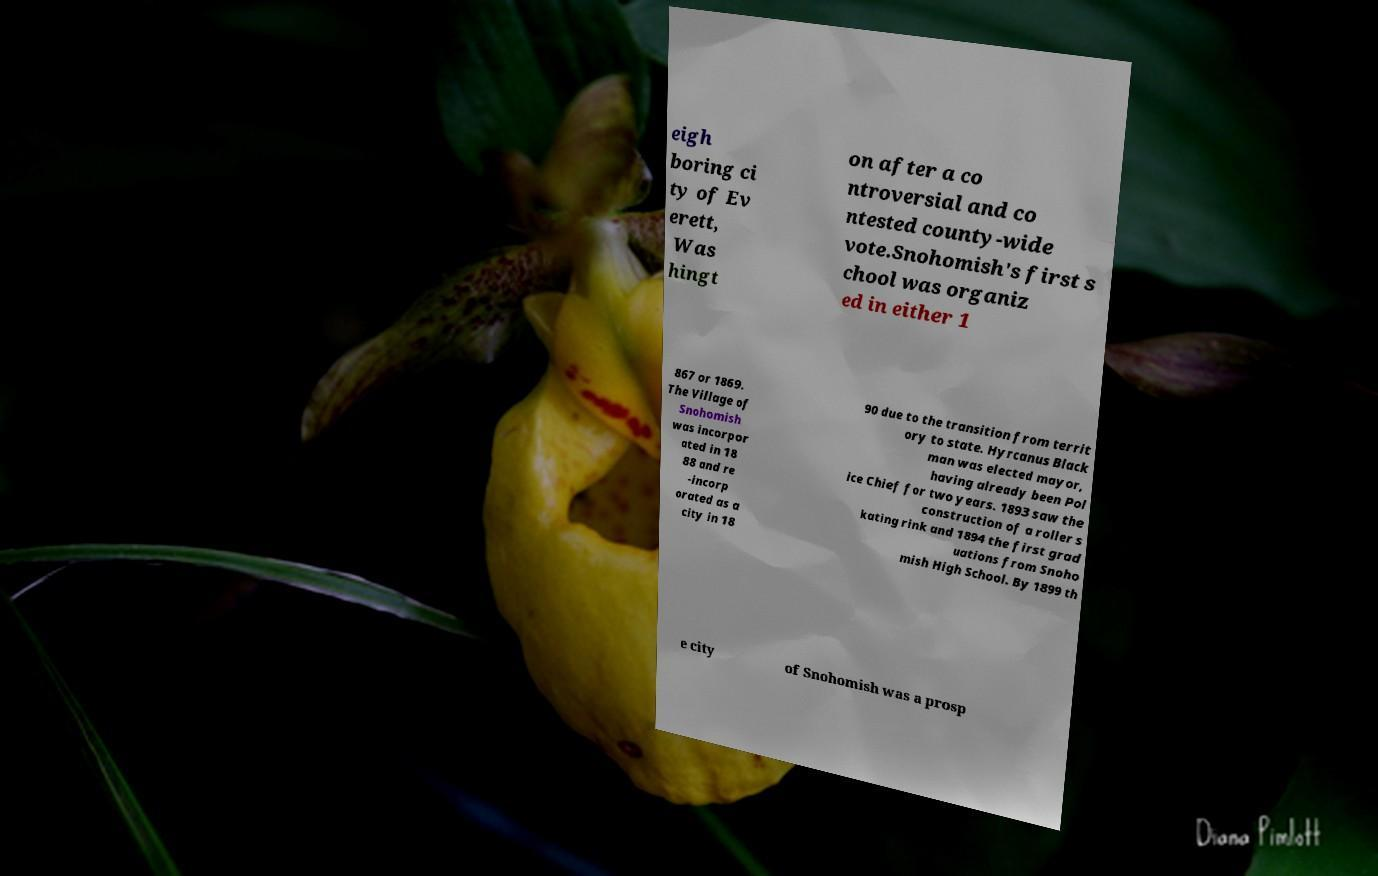Could you extract and type out the text from this image? eigh boring ci ty of Ev erett, Was hingt on after a co ntroversial and co ntested county-wide vote.Snohomish's first s chool was organiz ed in either 1 867 or 1869. The Village of Snohomish was incorpor ated in 18 88 and re -incorp orated as a city in 18 90 due to the transition from territ ory to state. Hyrcanus Black man was elected mayor, having already been Pol ice Chief for two years. 1893 saw the construction of a roller s kating rink and 1894 the first grad uations from Snoho mish High School. By 1899 th e city of Snohomish was a prosp 